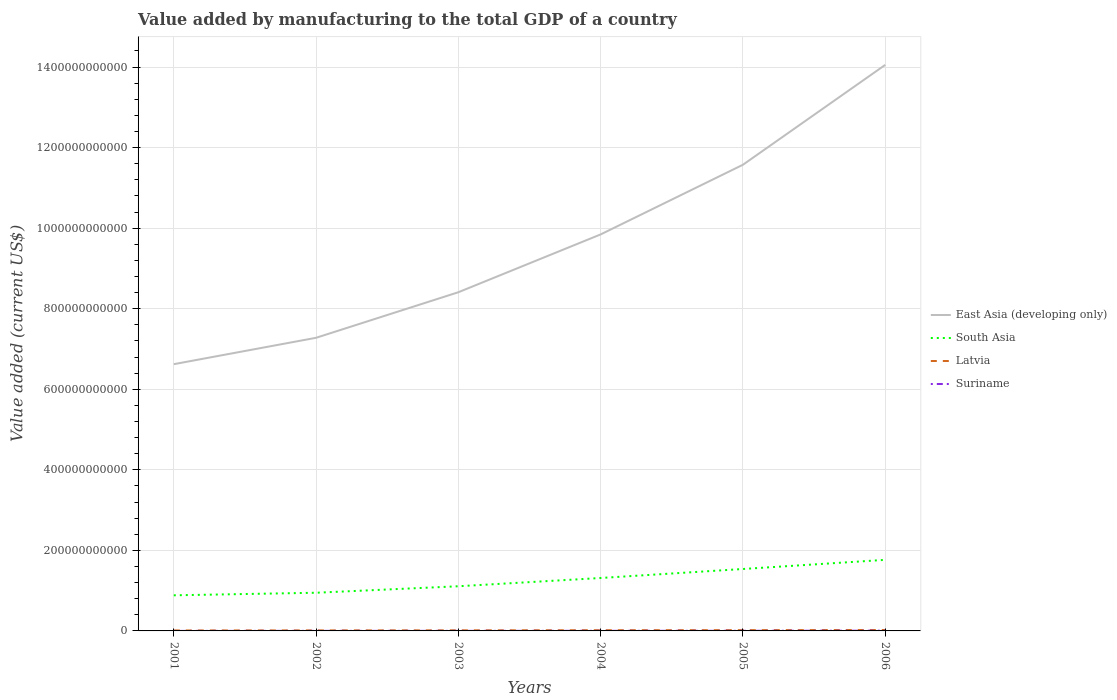How many different coloured lines are there?
Ensure brevity in your answer.  4. Does the line corresponding to Latvia intersect with the line corresponding to South Asia?
Provide a succinct answer. No. Across all years, what is the maximum value added by manufacturing to the total GDP in Suriname?
Give a very brief answer. 4.43e+07. In which year was the value added by manufacturing to the total GDP in East Asia (developing only) maximum?
Provide a succinct answer. 2001. What is the total value added by manufacturing to the total GDP in Suriname in the graph?
Ensure brevity in your answer.  -4.64e+08. What is the difference between the highest and the second highest value added by manufacturing to the total GDP in Suriname?
Your answer should be very brief. 5.65e+08. Is the value added by manufacturing to the total GDP in South Asia strictly greater than the value added by manufacturing to the total GDP in Latvia over the years?
Offer a terse response. No. How many years are there in the graph?
Provide a succinct answer. 6. What is the difference between two consecutive major ticks on the Y-axis?
Provide a short and direct response. 2.00e+11. Are the values on the major ticks of Y-axis written in scientific E-notation?
Keep it short and to the point. No. Where does the legend appear in the graph?
Make the answer very short. Center right. How are the legend labels stacked?
Provide a short and direct response. Vertical. What is the title of the graph?
Your answer should be very brief. Value added by manufacturing to the total GDP of a country. Does "Jordan" appear as one of the legend labels in the graph?
Your answer should be very brief. No. What is the label or title of the Y-axis?
Your response must be concise. Value added (current US$). What is the Value added (current US$) in East Asia (developing only) in 2001?
Your response must be concise. 6.62e+11. What is the Value added (current US$) in South Asia in 2001?
Provide a short and direct response. 8.84e+1. What is the Value added (current US$) of Latvia in 2001?
Your answer should be compact. 1.14e+09. What is the Value added (current US$) in Suriname in 2001?
Your response must be concise. 4.43e+07. What is the Value added (current US$) in East Asia (developing only) in 2002?
Keep it short and to the point. 7.28e+11. What is the Value added (current US$) in South Asia in 2002?
Give a very brief answer. 9.48e+1. What is the Value added (current US$) in Latvia in 2002?
Offer a very short reply. 1.30e+09. What is the Value added (current US$) in Suriname in 2002?
Ensure brevity in your answer.  1.45e+08. What is the Value added (current US$) of East Asia (developing only) in 2003?
Keep it short and to the point. 8.41e+11. What is the Value added (current US$) of South Asia in 2003?
Your response must be concise. 1.11e+11. What is the Value added (current US$) of Latvia in 2003?
Offer a very short reply. 1.46e+09. What is the Value added (current US$) of Suriname in 2003?
Make the answer very short. 1.62e+08. What is the Value added (current US$) in East Asia (developing only) in 2004?
Keep it short and to the point. 9.84e+11. What is the Value added (current US$) of South Asia in 2004?
Your response must be concise. 1.31e+11. What is the Value added (current US$) in Latvia in 2004?
Give a very brief answer. 1.78e+09. What is the Value added (current US$) of Suriname in 2004?
Provide a succinct answer. 2.27e+08. What is the Value added (current US$) of East Asia (developing only) in 2005?
Provide a succinct answer. 1.16e+12. What is the Value added (current US$) in South Asia in 2005?
Provide a succinct answer. 1.54e+11. What is the Value added (current US$) of Latvia in 2005?
Keep it short and to the point. 1.95e+09. What is the Value added (current US$) of Suriname in 2005?
Your response must be concise. 2.99e+08. What is the Value added (current US$) in East Asia (developing only) in 2006?
Offer a terse response. 1.41e+12. What is the Value added (current US$) of South Asia in 2006?
Your answer should be compact. 1.76e+11. What is the Value added (current US$) in Latvia in 2006?
Your answer should be very brief. 2.29e+09. What is the Value added (current US$) of Suriname in 2006?
Give a very brief answer. 6.09e+08. Across all years, what is the maximum Value added (current US$) of East Asia (developing only)?
Provide a succinct answer. 1.41e+12. Across all years, what is the maximum Value added (current US$) of South Asia?
Keep it short and to the point. 1.76e+11. Across all years, what is the maximum Value added (current US$) in Latvia?
Offer a terse response. 2.29e+09. Across all years, what is the maximum Value added (current US$) of Suriname?
Ensure brevity in your answer.  6.09e+08. Across all years, what is the minimum Value added (current US$) in East Asia (developing only)?
Offer a very short reply. 6.62e+11. Across all years, what is the minimum Value added (current US$) in South Asia?
Your response must be concise. 8.84e+1. Across all years, what is the minimum Value added (current US$) of Latvia?
Make the answer very short. 1.14e+09. Across all years, what is the minimum Value added (current US$) in Suriname?
Keep it short and to the point. 4.43e+07. What is the total Value added (current US$) of East Asia (developing only) in the graph?
Your answer should be very brief. 5.78e+12. What is the total Value added (current US$) in South Asia in the graph?
Your answer should be compact. 7.56e+11. What is the total Value added (current US$) of Latvia in the graph?
Give a very brief answer. 9.93e+09. What is the total Value added (current US$) in Suriname in the graph?
Keep it short and to the point. 1.49e+09. What is the difference between the Value added (current US$) in East Asia (developing only) in 2001 and that in 2002?
Your answer should be compact. -6.55e+1. What is the difference between the Value added (current US$) in South Asia in 2001 and that in 2002?
Your answer should be compact. -6.36e+09. What is the difference between the Value added (current US$) of Latvia in 2001 and that in 2002?
Offer a terse response. -1.57e+08. What is the difference between the Value added (current US$) in Suriname in 2001 and that in 2002?
Your answer should be very brief. -1.01e+08. What is the difference between the Value added (current US$) of East Asia (developing only) in 2001 and that in 2003?
Your response must be concise. -1.79e+11. What is the difference between the Value added (current US$) in South Asia in 2001 and that in 2003?
Provide a succinct answer. -2.25e+1. What is the difference between the Value added (current US$) of Latvia in 2001 and that in 2003?
Provide a short and direct response. -3.19e+08. What is the difference between the Value added (current US$) in Suriname in 2001 and that in 2003?
Your answer should be very brief. -1.18e+08. What is the difference between the Value added (current US$) in East Asia (developing only) in 2001 and that in 2004?
Give a very brief answer. -3.22e+11. What is the difference between the Value added (current US$) in South Asia in 2001 and that in 2004?
Offer a very short reply. -4.30e+1. What is the difference between the Value added (current US$) in Latvia in 2001 and that in 2004?
Offer a very short reply. -6.35e+08. What is the difference between the Value added (current US$) in Suriname in 2001 and that in 2004?
Your answer should be compact. -1.83e+08. What is the difference between the Value added (current US$) in East Asia (developing only) in 2001 and that in 2005?
Keep it short and to the point. -4.95e+11. What is the difference between the Value added (current US$) in South Asia in 2001 and that in 2005?
Give a very brief answer. -6.53e+1. What is the difference between the Value added (current US$) in Latvia in 2001 and that in 2005?
Your answer should be compact. -8.05e+08. What is the difference between the Value added (current US$) of Suriname in 2001 and that in 2005?
Offer a very short reply. -2.55e+08. What is the difference between the Value added (current US$) in East Asia (developing only) in 2001 and that in 2006?
Your response must be concise. -7.43e+11. What is the difference between the Value added (current US$) of South Asia in 2001 and that in 2006?
Provide a short and direct response. -8.80e+1. What is the difference between the Value added (current US$) in Latvia in 2001 and that in 2006?
Give a very brief answer. -1.14e+09. What is the difference between the Value added (current US$) in Suriname in 2001 and that in 2006?
Make the answer very short. -5.65e+08. What is the difference between the Value added (current US$) in East Asia (developing only) in 2002 and that in 2003?
Provide a succinct answer. -1.13e+11. What is the difference between the Value added (current US$) in South Asia in 2002 and that in 2003?
Ensure brevity in your answer.  -1.61e+1. What is the difference between the Value added (current US$) in Latvia in 2002 and that in 2003?
Ensure brevity in your answer.  -1.62e+08. What is the difference between the Value added (current US$) of Suriname in 2002 and that in 2003?
Ensure brevity in your answer.  -1.69e+07. What is the difference between the Value added (current US$) in East Asia (developing only) in 2002 and that in 2004?
Ensure brevity in your answer.  -2.57e+11. What is the difference between the Value added (current US$) in South Asia in 2002 and that in 2004?
Offer a very short reply. -3.66e+1. What is the difference between the Value added (current US$) of Latvia in 2002 and that in 2004?
Keep it short and to the point. -4.78e+08. What is the difference between the Value added (current US$) in Suriname in 2002 and that in 2004?
Offer a very short reply. -8.15e+07. What is the difference between the Value added (current US$) in East Asia (developing only) in 2002 and that in 2005?
Make the answer very short. -4.30e+11. What is the difference between the Value added (current US$) in South Asia in 2002 and that in 2005?
Provide a succinct answer. -5.90e+1. What is the difference between the Value added (current US$) of Latvia in 2002 and that in 2005?
Provide a succinct answer. -6.48e+08. What is the difference between the Value added (current US$) in Suriname in 2002 and that in 2005?
Keep it short and to the point. -1.54e+08. What is the difference between the Value added (current US$) in East Asia (developing only) in 2002 and that in 2006?
Your answer should be compact. -6.78e+11. What is the difference between the Value added (current US$) in South Asia in 2002 and that in 2006?
Give a very brief answer. -8.17e+1. What is the difference between the Value added (current US$) in Latvia in 2002 and that in 2006?
Give a very brief answer. -9.87e+08. What is the difference between the Value added (current US$) of Suriname in 2002 and that in 2006?
Give a very brief answer. -4.64e+08. What is the difference between the Value added (current US$) in East Asia (developing only) in 2003 and that in 2004?
Give a very brief answer. -1.44e+11. What is the difference between the Value added (current US$) of South Asia in 2003 and that in 2004?
Keep it short and to the point. -2.05e+1. What is the difference between the Value added (current US$) of Latvia in 2003 and that in 2004?
Provide a short and direct response. -3.16e+08. What is the difference between the Value added (current US$) in Suriname in 2003 and that in 2004?
Give a very brief answer. -6.46e+07. What is the difference between the Value added (current US$) in East Asia (developing only) in 2003 and that in 2005?
Your response must be concise. -3.17e+11. What is the difference between the Value added (current US$) of South Asia in 2003 and that in 2005?
Offer a very short reply. -4.29e+1. What is the difference between the Value added (current US$) in Latvia in 2003 and that in 2005?
Offer a terse response. -4.86e+08. What is the difference between the Value added (current US$) in Suriname in 2003 and that in 2005?
Your answer should be very brief. -1.37e+08. What is the difference between the Value added (current US$) in East Asia (developing only) in 2003 and that in 2006?
Offer a very short reply. -5.64e+11. What is the difference between the Value added (current US$) of South Asia in 2003 and that in 2006?
Your answer should be very brief. -6.56e+1. What is the difference between the Value added (current US$) of Latvia in 2003 and that in 2006?
Your answer should be very brief. -8.25e+08. What is the difference between the Value added (current US$) of Suriname in 2003 and that in 2006?
Offer a terse response. -4.47e+08. What is the difference between the Value added (current US$) in East Asia (developing only) in 2004 and that in 2005?
Make the answer very short. -1.73e+11. What is the difference between the Value added (current US$) of South Asia in 2004 and that in 2005?
Make the answer very short. -2.23e+1. What is the difference between the Value added (current US$) of Latvia in 2004 and that in 2005?
Your answer should be very brief. -1.70e+08. What is the difference between the Value added (current US$) of Suriname in 2004 and that in 2005?
Your answer should be compact. -7.25e+07. What is the difference between the Value added (current US$) in East Asia (developing only) in 2004 and that in 2006?
Make the answer very short. -4.21e+11. What is the difference between the Value added (current US$) in South Asia in 2004 and that in 2006?
Ensure brevity in your answer.  -4.51e+1. What is the difference between the Value added (current US$) in Latvia in 2004 and that in 2006?
Offer a terse response. -5.09e+08. What is the difference between the Value added (current US$) in Suriname in 2004 and that in 2006?
Provide a short and direct response. -3.82e+08. What is the difference between the Value added (current US$) of East Asia (developing only) in 2005 and that in 2006?
Offer a terse response. -2.48e+11. What is the difference between the Value added (current US$) in South Asia in 2005 and that in 2006?
Give a very brief answer. -2.27e+1. What is the difference between the Value added (current US$) of Latvia in 2005 and that in 2006?
Your answer should be very brief. -3.40e+08. What is the difference between the Value added (current US$) of Suriname in 2005 and that in 2006?
Ensure brevity in your answer.  -3.10e+08. What is the difference between the Value added (current US$) in East Asia (developing only) in 2001 and the Value added (current US$) in South Asia in 2002?
Your response must be concise. 5.67e+11. What is the difference between the Value added (current US$) of East Asia (developing only) in 2001 and the Value added (current US$) of Latvia in 2002?
Give a very brief answer. 6.61e+11. What is the difference between the Value added (current US$) in East Asia (developing only) in 2001 and the Value added (current US$) in Suriname in 2002?
Make the answer very short. 6.62e+11. What is the difference between the Value added (current US$) in South Asia in 2001 and the Value added (current US$) in Latvia in 2002?
Your answer should be compact. 8.71e+1. What is the difference between the Value added (current US$) in South Asia in 2001 and the Value added (current US$) in Suriname in 2002?
Make the answer very short. 8.83e+1. What is the difference between the Value added (current US$) of Latvia in 2001 and the Value added (current US$) of Suriname in 2002?
Provide a succinct answer. 9.99e+08. What is the difference between the Value added (current US$) in East Asia (developing only) in 2001 and the Value added (current US$) in South Asia in 2003?
Your answer should be compact. 5.51e+11. What is the difference between the Value added (current US$) in East Asia (developing only) in 2001 and the Value added (current US$) in Latvia in 2003?
Make the answer very short. 6.61e+11. What is the difference between the Value added (current US$) of East Asia (developing only) in 2001 and the Value added (current US$) of Suriname in 2003?
Your answer should be very brief. 6.62e+11. What is the difference between the Value added (current US$) of South Asia in 2001 and the Value added (current US$) of Latvia in 2003?
Make the answer very short. 8.70e+1. What is the difference between the Value added (current US$) in South Asia in 2001 and the Value added (current US$) in Suriname in 2003?
Offer a terse response. 8.83e+1. What is the difference between the Value added (current US$) in Latvia in 2001 and the Value added (current US$) in Suriname in 2003?
Make the answer very short. 9.83e+08. What is the difference between the Value added (current US$) in East Asia (developing only) in 2001 and the Value added (current US$) in South Asia in 2004?
Offer a very short reply. 5.31e+11. What is the difference between the Value added (current US$) in East Asia (developing only) in 2001 and the Value added (current US$) in Latvia in 2004?
Your response must be concise. 6.60e+11. What is the difference between the Value added (current US$) of East Asia (developing only) in 2001 and the Value added (current US$) of Suriname in 2004?
Ensure brevity in your answer.  6.62e+11. What is the difference between the Value added (current US$) of South Asia in 2001 and the Value added (current US$) of Latvia in 2004?
Offer a terse response. 8.66e+1. What is the difference between the Value added (current US$) of South Asia in 2001 and the Value added (current US$) of Suriname in 2004?
Ensure brevity in your answer.  8.82e+1. What is the difference between the Value added (current US$) of Latvia in 2001 and the Value added (current US$) of Suriname in 2004?
Provide a succinct answer. 9.18e+08. What is the difference between the Value added (current US$) in East Asia (developing only) in 2001 and the Value added (current US$) in South Asia in 2005?
Keep it short and to the point. 5.09e+11. What is the difference between the Value added (current US$) of East Asia (developing only) in 2001 and the Value added (current US$) of Latvia in 2005?
Your response must be concise. 6.60e+11. What is the difference between the Value added (current US$) of East Asia (developing only) in 2001 and the Value added (current US$) of Suriname in 2005?
Offer a very short reply. 6.62e+11. What is the difference between the Value added (current US$) in South Asia in 2001 and the Value added (current US$) in Latvia in 2005?
Ensure brevity in your answer.  8.65e+1. What is the difference between the Value added (current US$) in South Asia in 2001 and the Value added (current US$) in Suriname in 2005?
Ensure brevity in your answer.  8.81e+1. What is the difference between the Value added (current US$) of Latvia in 2001 and the Value added (current US$) of Suriname in 2005?
Give a very brief answer. 8.45e+08. What is the difference between the Value added (current US$) of East Asia (developing only) in 2001 and the Value added (current US$) of South Asia in 2006?
Ensure brevity in your answer.  4.86e+11. What is the difference between the Value added (current US$) in East Asia (developing only) in 2001 and the Value added (current US$) in Latvia in 2006?
Ensure brevity in your answer.  6.60e+11. What is the difference between the Value added (current US$) of East Asia (developing only) in 2001 and the Value added (current US$) of Suriname in 2006?
Your answer should be very brief. 6.62e+11. What is the difference between the Value added (current US$) of South Asia in 2001 and the Value added (current US$) of Latvia in 2006?
Offer a very short reply. 8.61e+1. What is the difference between the Value added (current US$) of South Asia in 2001 and the Value added (current US$) of Suriname in 2006?
Give a very brief answer. 8.78e+1. What is the difference between the Value added (current US$) in Latvia in 2001 and the Value added (current US$) in Suriname in 2006?
Provide a short and direct response. 5.36e+08. What is the difference between the Value added (current US$) of East Asia (developing only) in 2002 and the Value added (current US$) of South Asia in 2003?
Give a very brief answer. 6.17e+11. What is the difference between the Value added (current US$) in East Asia (developing only) in 2002 and the Value added (current US$) in Latvia in 2003?
Offer a terse response. 7.26e+11. What is the difference between the Value added (current US$) of East Asia (developing only) in 2002 and the Value added (current US$) of Suriname in 2003?
Provide a short and direct response. 7.28e+11. What is the difference between the Value added (current US$) of South Asia in 2002 and the Value added (current US$) of Latvia in 2003?
Provide a succinct answer. 9.33e+1. What is the difference between the Value added (current US$) of South Asia in 2002 and the Value added (current US$) of Suriname in 2003?
Your response must be concise. 9.46e+1. What is the difference between the Value added (current US$) of Latvia in 2002 and the Value added (current US$) of Suriname in 2003?
Ensure brevity in your answer.  1.14e+09. What is the difference between the Value added (current US$) of East Asia (developing only) in 2002 and the Value added (current US$) of South Asia in 2004?
Give a very brief answer. 5.96e+11. What is the difference between the Value added (current US$) of East Asia (developing only) in 2002 and the Value added (current US$) of Latvia in 2004?
Offer a very short reply. 7.26e+11. What is the difference between the Value added (current US$) in East Asia (developing only) in 2002 and the Value added (current US$) in Suriname in 2004?
Provide a short and direct response. 7.28e+11. What is the difference between the Value added (current US$) in South Asia in 2002 and the Value added (current US$) in Latvia in 2004?
Make the answer very short. 9.30e+1. What is the difference between the Value added (current US$) in South Asia in 2002 and the Value added (current US$) in Suriname in 2004?
Make the answer very short. 9.46e+1. What is the difference between the Value added (current US$) of Latvia in 2002 and the Value added (current US$) of Suriname in 2004?
Offer a very short reply. 1.08e+09. What is the difference between the Value added (current US$) of East Asia (developing only) in 2002 and the Value added (current US$) of South Asia in 2005?
Offer a very short reply. 5.74e+11. What is the difference between the Value added (current US$) of East Asia (developing only) in 2002 and the Value added (current US$) of Latvia in 2005?
Give a very brief answer. 7.26e+11. What is the difference between the Value added (current US$) in East Asia (developing only) in 2002 and the Value added (current US$) in Suriname in 2005?
Keep it short and to the point. 7.27e+11. What is the difference between the Value added (current US$) of South Asia in 2002 and the Value added (current US$) of Latvia in 2005?
Ensure brevity in your answer.  9.28e+1. What is the difference between the Value added (current US$) in South Asia in 2002 and the Value added (current US$) in Suriname in 2005?
Your answer should be very brief. 9.45e+1. What is the difference between the Value added (current US$) in Latvia in 2002 and the Value added (current US$) in Suriname in 2005?
Offer a very short reply. 1.00e+09. What is the difference between the Value added (current US$) of East Asia (developing only) in 2002 and the Value added (current US$) of South Asia in 2006?
Ensure brevity in your answer.  5.51e+11. What is the difference between the Value added (current US$) of East Asia (developing only) in 2002 and the Value added (current US$) of Latvia in 2006?
Keep it short and to the point. 7.25e+11. What is the difference between the Value added (current US$) in East Asia (developing only) in 2002 and the Value added (current US$) in Suriname in 2006?
Your answer should be very brief. 7.27e+11. What is the difference between the Value added (current US$) in South Asia in 2002 and the Value added (current US$) in Latvia in 2006?
Offer a very short reply. 9.25e+1. What is the difference between the Value added (current US$) of South Asia in 2002 and the Value added (current US$) of Suriname in 2006?
Your response must be concise. 9.42e+1. What is the difference between the Value added (current US$) of Latvia in 2002 and the Value added (current US$) of Suriname in 2006?
Keep it short and to the point. 6.93e+08. What is the difference between the Value added (current US$) of East Asia (developing only) in 2003 and the Value added (current US$) of South Asia in 2004?
Your response must be concise. 7.09e+11. What is the difference between the Value added (current US$) in East Asia (developing only) in 2003 and the Value added (current US$) in Latvia in 2004?
Offer a very short reply. 8.39e+11. What is the difference between the Value added (current US$) of East Asia (developing only) in 2003 and the Value added (current US$) of Suriname in 2004?
Your answer should be compact. 8.41e+11. What is the difference between the Value added (current US$) of South Asia in 2003 and the Value added (current US$) of Latvia in 2004?
Ensure brevity in your answer.  1.09e+11. What is the difference between the Value added (current US$) of South Asia in 2003 and the Value added (current US$) of Suriname in 2004?
Make the answer very short. 1.11e+11. What is the difference between the Value added (current US$) in Latvia in 2003 and the Value added (current US$) in Suriname in 2004?
Ensure brevity in your answer.  1.24e+09. What is the difference between the Value added (current US$) of East Asia (developing only) in 2003 and the Value added (current US$) of South Asia in 2005?
Provide a succinct answer. 6.87e+11. What is the difference between the Value added (current US$) of East Asia (developing only) in 2003 and the Value added (current US$) of Latvia in 2005?
Offer a very short reply. 8.39e+11. What is the difference between the Value added (current US$) of East Asia (developing only) in 2003 and the Value added (current US$) of Suriname in 2005?
Your answer should be compact. 8.41e+11. What is the difference between the Value added (current US$) of South Asia in 2003 and the Value added (current US$) of Latvia in 2005?
Your answer should be very brief. 1.09e+11. What is the difference between the Value added (current US$) in South Asia in 2003 and the Value added (current US$) in Suriname in 2005?
Give a very brief answer. 1.11e+11. What is the difference between the Value added (current US$) in Latvia in 2003 and the Value added (current US$) in Suriname in 2005?
Offer a terse response. 1.16e+09. What is the difference between the Value added (current US$) of East Asia (developing only) in 2003 and the Value added (current US$) of South Asia in 2006?
Offer a very short reply. 6.64e+11. What is the difference between the Value added (current US$) in East Asia (developing only) in 2003 and the Value added (current US$) in Latvia in 2006?
Ensure brevity in your answer.  8.39e+11. What is the difference between the Value added (current US$) in East Asia (developing only) in 2003 and the Value added (current US$) in Suriname in 2006?
Keep it short and to the point. 8.40e+11. What is the difference between the Value added (current US$) of South Asia in 2003 and the Value added (current US$) of Latvia in 2006?
Ensure brevity in your answer.  1.09e+11. What is the difference between the Value added (current US$) in South Asia in 2003 and the Value added (current US$) in Suriname in 2006?
Give a very brief answer. 1.10e+11. What is the difference between the Value added (current US$) in Latvia in 2003 and the Value added (current US$) in Suriname in 2006?
Offer a very short reply. 8.55e+08. What is the difference between the Value added (current US$) of East Asia (developing only) in 2004 and the Value added (current US$) of South Asia in 2005?
Provide a succinct answer. 8.31e+11. What is the difference between the Value added (current US$) in East Asia (developing only) in 2004 and the Value added (current US$) in Latvia in 2005?
Offer a very short reply. 9.82e+11. What is the difference between the Value added (current US$) of East Asia (developing only) in 2004 and the Value added (current US$) of Suriname in 2005?
Provide a succinct answer. 9.84e+11. What is the difference between the Value added (current US$) of South Asia in 2004 and the Value added (current US$) of Latvia in 2005?
Keep it short and to the point. 1.29e+11. What is the difference between the Value added (current US$) of South Asia in 2004 and the Value added (current US$) of Suriname in 2005?
Give a very brief answer. 1.31e+11. What is the difference between the Value added (current US$) of Latvia in 2004 and the Value added (current US$) of Suriname in 2005?
Offer a very short reply. 1.48e+09. What is the difference between the Value added (current US$) in East Asia (developing only) in 2004 and the Value added (current US$) in South Asia in 2006?
Your response must be concise. 8.08e+11. What is the difference between the Value added (current US$) in East Asia (developing only) in 2004 and the Value added (current US$) in Latvia in 2006?
Keep it short and to the point. 9.82e+11. What is the difference between the Value added (current US$) of East Asia (developing only) in 2004 and the Value added (current US$) of Suriname in 2006?
Make the answer very short. 9.84e+11. What is the difference between the Value added (current US$) of South Asia in 2004 and the Value added (current US$) of Latvia in 2006?
Provide a short and direct response. 1.29e+11. What is the difference between the Value added (current US$) of South Asia in 2004 and the Value added (current US$) of Suriname in 2006?
Make the answer very short. 1.31e+11. What is the difference between the Value added (current US$) in Latvia in 2004 and the Value added (current US$) in Suriname in 2006?
Your response must be concise. 1.17e+09. What is the difference between the Value added (current US$) in East Asia (developing only) in 2005 and the Value added (current US$) in South Asia in 2006?
Keep it short and to the point. 9.81e+11. What is the difference between the Value added (current US$) in East Asia (developing only) in 2005 and the Value added (current US$) in Latvia in 2006?
Give a very brief answer. 1.16e+12. What is the difference between the Value added (current US$) in East Asia (developing only) in 2005 and the Value added (current US$) in Suriname in 2006?
Offer a very short reply. 1.16e+12. What is the difference between the Value added (current US$) in South Asia in 2005 and the Value added (current US$) in Latvia in 2006?
Your answer should be very brief. 1.51e+11. What is the difference between the Value added (current US$) in South Asia in 2005 and the Value added (current US$) in Suriname in 2006?
Offer a very short reply. 1.53e+11. What is the difference between the Value added (current US$) in Latvia in 2005 and the Value added (current US$) in Suriname in 2006?
Your answer should be very brief. 1.34e+09. What is the average Value added (current US$) in East Asia (developing only) per year?
Your answer should be compact. 9.63e+11. What is the average Value added (current US$) of South Asia per year?
Provide a short and direct response. 1.26e+11. What is the average Value added (current US$) in Latvia per year?
Make the answer very short. 1.66e+09. What is the average Value added (current US$) of Suriname per year?
Offer a terse response. 2.48e+08. In the year 2001, what is the difference between the Value added (current US$) of East Asia (developing only) and Value added (current US$) of South Asia?
Your response must be concise. 5.74e+11. In the year 2001, what is the difference between the Value added (current US$) of East Asia (developing only) and Value added (current US$) of Latvia?
Your response must be concise. 6.61e+11. In the year 2001, what is the difference between the Value added (current US$) in East Asia (developing only) and Value added (current US$) in Suriname?
Offer a terse response. 6.62e+11. In the year 2001, what is the difference between the Value added (current US$) of South Asia and Value added (current US$) of Latvia?
Ensure brevity in your answer.  8.73e+1. In the year 2001, what is the difference between the Value added (current US$) of South Asia and Value added (current US$) of Suriname?
Offer a very short reply. 8.84e+1. In the year 2001, what is the difference between the Value added (current US$) of Latvia and Value added (current US$) of Suriname?
Ensure brevity in your answer.  1.10e+09. In the year 2002, what is the difference between the Value added (current US$) in East Asia (developing only) and Value added (current US$) in South Asia?
Provide a succinct answer. 6.33e+11. In the year 2002, what is the difference between the Value added (current US$) in East Asia (developing only) and Value added (current US$) in Latvia?
Provide a short and direct response. 7.26e+11. In the year 2002, what is the difference between the Value added (current US$) of East Asia (developing only) and Value added (current US$) of Suriname?
Your answer should be compact. 7.28e+11. In the year 2002, what is the difference between the Value added (current US$) in South Asia and Value added (current US$) in Latvia?
Your response must be concise. 9.35e+1. In the year 2002, what is the difference between the Value added (current US$) in South Asia and Value added (current US$) in Suriname?
Your answer should be very brief. 9.46e+1. In the year 2002, what is the difference between the Value added (current US$) in Latvia and Value added (current US$) in Suriname?
Keep it short and to the point. 1.16e+09. In the year 2003, what is the difference between the Value added (current US$) in East Asia (developing only) and Value added (current US$) in South Asia?
Keep it short and to the point. 7.30e+11. In the year 2003, what is the difference between the Value added (current US$) of East Asia (developing only) and Value added (current US$) of Latvia?
Provide a succinct answer. 8.39e+11. In the year 2003, what is the difference between the Value added (current US$) of East Asia (developing only) and Value added (current US$) of Suriname?
Your answer should be compact. 8.41e+11. In the year 2003, what is the difference between the Value added (current US$) in South Asia and Value added (current US$) in Latvia?
Offer a very short reply. 1.09e+11. In the year 2003, what is the difference between the Value added (current US$) of South Asia and Value added (current US$) of Suriname?
Your response must be concise. 1.11e+11. In the year 2003, what is the difference between the Value added (current US$) of Latvia and Value added (current US$) of Suriname?
Your answer should be compact. 1.30e+09. In the year 2004, what is the difference between the Value added (current US$) of East Asia (developing only) and Value added (current US$) of South Asia?
Ensure brevity in your answer.  8.53e+11. In the year 2004, what is the difference between the Value added (current US$) of East Asia (developing only) and Value added (current US$) of Latvia?
Offer a very short reply. 9.83e+11. In the year 2004, what is the difference between the Value added (current US$) in East Asia (developing only) and Value added (current US$) in Suriname?
Offer a very short reply. 9.84e+11. In the year 2004, what is the difference between the Value added (current US$) in South Asia and Value added (current US$) in Latvia?
Keep it short and to the point. 1.30e+11. In the year 2004, what is the difference between the Value added (current US$) of South Asia and Value added (current US$) of Suriname?
Ensure brevity in your answer.  1.31e+11. In the year 2004, what is the difference between the Value added (current US$) in Latvia and Value added (current US$) in Suriname?
Your answer should be very brief. 1.55e+09. In the year 2005, what is the difference between the Value added (current US$) in East Asia (developing only) and Value added (current US$) in South Asia?
Your response must be concise. 1.00e+12. In the year 2005, what is the difference between the Value added (current US$) in East Asia (developing only) and Value added (current US$) in Latvia?
Ensure brevity in your answer.  1.16e+12. In the year 2005, what is the difference between the Value added (current US$) in East Asia (developing only) and Value added (current US$) in Suriname?
Provide a succinct answer. 1.16e+12. In the year 2005, what is the difference between the Value added (current US$) of South Asia and Value added (current US$) of Latvia?
Give a very brief answer. 1.52e+11. In the year 2005, what is the difference between the Value added (current US$) in South Asia and Value added (current US$) in Suriname?
Give a very brief answer. 1.53e+11. In the year 2005, what is the difference between the Value added (current US$) of Latvia and Value added (current US$) of Suriname?
Your answer should be very brief. 1.65e+09. In the year 2006, what is the difference between the Value added (current US$) in East Asia (developing only) and Value added (current US$) in South Asia?
Provide a short and direct response. 1.23e+12. In the year 2006, what is the difference between the Value added (current US$) of East Asia (developing only) and Value added (current US$) of Latvia?
Your answer should be compact. 1.40e+12. In the year 2006, what is the difference between the Value added (current US$) of East Asia (developing only) and Value added (current US$) of Suriname?
Your answer should be very brief. 1.40e+12. In the year 2006, what is the difference between the Value added (current US$) in South Asia and Value added (current US$) in Latvia?
Ensure brevity in your answer.  1.74e+11. In the year 2006, what is the difference between the Value added (current US$) of South Asia and Value added (current US$) of Suriname?
Offer a terse response. 1.76e+11. In the year 2006, what is the difference between the Value added (current US$) of Latvia and Value added (current US$) of Suriname?
Give a very brief answer. 1.68e+09. What is the ratio of the Value added (current US$) in East Asia (developing only) in 2001 to that in 2002?
Your answer should be compact. 0.91. What is the ratio of the Value added (current US$) in South Asia in 2001 to that in 2002?
Your response must be concise. 0.93. What is the ratio of the Value added (current US$) in Latvia in 2001 to that in 2002?
Your response must be concise. 0.88. What is the ratio of the Value added (current US$) of Suriname in 2001 to that in 2002?
Offer a very short reply. 0.3. What is the ratio of the Value added (current US$) in East Asia (developing only) in 2001 to that in 2003?
Give a very brief answer. 0.79. What is the ratio of the Value added (current US$) of South Asia in 2001 to that in 2003?
Make the answer very short. 0.8. What is the ratio of the Value added (current US$) of Latvia in 2001 to that in 2003?
Make the answer very short. 0.78. What is the ratio of the Value added (current US$) in Suriname in 2001 to that in 2003?
Provide a short and direct response. 0.27. What is the ratio of the Value added (current US$) of East Asia (developing only) in 2001 to that in 2004?
Provide a short and direct response. 0.67. What is the ratio of the Value added (current US$) in South Asia in 2001 to that in 2004?
Make the answer very short. 0.67. What is the ratio of the Value added (current US$) in Latvia in 2001 to that in 2004?
Your answer should be very brief. 0.64. What is the ratio of the Value added (current US$) in Suriname in 2001 to that in 2004?
Your answer should be compact. 0.2. What is the ratio of the Value added (current US$) in East Asia (developing only) in 2001 to that in 2005?
Offer a terse response. 0.57. What is the ratio of the Value added (current US$) of South Asia in 2001 to that in 2005?
Your answer should be compact. 0.58. What is the ratio of the Value added (current US$) of Latvia in 2001 to that in 2005?
Make the answer very short. 0.59. What is the ratio of the Value added (current US$) of Suriname in 2001 to that in 2005?
Ensure brevity in your answer.  0.15. What is the ratio of the Value added (current US$) in East Asia (developing only) in 2001 to that in 2006?
Make the answer very short. 0.47. What is the ratio of the Value added (current US$) in South Asia in 2001 to that in 2006?
Make the answer very short. 0.5. What is the ratio of the Value added (current US$) in Latvia in 2001 to that in 2006?
Keep it short and to the point. 0.5. What is the ratio of the Value added (current US$) of Suriname in 2001 to that in 2006?
Provide a succinct answer. 0.07. What is the ratio of the Value added (current US$) in East Asia (developing only) in 2002 to that in 2003?
Your answer should be compact. 0.87. What is the ratio of the Value added (current US$) of South Asia in 2002 to that in 2003?
Keep it short and to the point. 0.85. What is the ratio of the Value added (current US$) of Latvia in 2002 to that in 2003?
Your answer should be compact. 0.89. What is the ratio of the Value added (current US$) of Suriname in 2002 to that in 2003?
Your answer should be compact. 0.9. What is the ratio of the Value added (current US$) in East Asia (developing only) in 2002 to that in 2004?
Your answer should be compact. 0.74. What is the ratio of the Value added (current US$) in South Asia in 2002 to that in 2004?
Offer a terse response. 0.72. What is the ratio of the Value added (current US$) in Latvia in 2002 to that in 2004?
Keep it short and to the point. 0.73. What is the ratio of the Value added (current US$) in Suriname in 2002 to that in 2004?
Provide a succinct answer. 0.64. What is the ratio of the Value added (current US$) in East Asia (developing only) in 2002 to that in 2005?
Provide a succinct answer. 0.63. What is the ratio of the Value added (current US$) of South Asia in 2002 to that in 2005?
Ensure brevity in your answer.  0.62. What is the ratio of the Value added (current US$) in Latvia in 2002 to that in 2005?
Offer a terse response. 0.67. What is the ratio of the Value added (current US$) in Suriname in 2002 to that in 2005?
Offer a terse response. 0.49. What is the ratio of the Value added (current US$) in East Asia (developing only) in 2002 to that in 2006?
Your answer should be compact. 0.52. What is the ratio of the Value added (current US$) in South Asia in 2002 to that in 2006?
Offer a very short reply. 0.54. What is the ratio of the Value added (current US$) in Latvia in 2002 to that in 2006?
Keep it short and to the point. 0.57. What is the ratio of the Value added (current US$) in Suriname in 2002 to that in 2006?
Your answer should be very brief. 0.24. What is the ratio of the Value added (current US$) of East Asia (developing only) in 2003 to that in 2004?
Give a very brief answer. 0.85. What is the ratio of the Value added (current US$) in South Asia in 2003 to that in 2004?
Make the answer very short. 0.84. What is the ratio of the Value added (current US$) in Latvia in 2003 to that in 2004?
Offer a terse response. 0.82. What is the ratio of the Value added (current US$) of Suriname in 2003 to that in 2004?
Your answer should be very brief. 0.72. What is the ratio of the Value added (current US$) in East Asia (developing only) in 2003 to that in 2005?
Keep it short and to the point. 0.73. What is the ratio of the Value added (current US$) of South Asia in 2003 to that in 2005?
Offer a terse response. 0.72. What is the ratio of the Value added (current US$) of Latvia in 2003 to that in 2005?
Offer a terse response. 0.75. What is the ratio of the Value added (current US$) in Suriname in 2003 to that in 2005?
Provide a short and direct response. 0.54. What is the ratio of the Value added (current US$) of East Asia (developing only) in 2003 to that in 2006?
Offer a very short reply. 0.6. What is the ratio of the Value added (current US$) in South Asia in 2003 to that in 2006?
Your response must be concise. 0.63. What is the ratio of the Value added (current US$) of Latvia in 2003 to that in 2006?
Ensure brevity in your answer.  0.64. What is the ratio of the Value added (current US$) in Suriname in 2003 to that in 2006?
Offer a very short reply. 0.27. What is the ratio of the Value added (current US$) of East Asia (developing only) in 2004 to that in 2005?
Offer a terse response. 0.85. What is the ratio of the Value added (current US$) of South Asia in 2004 to that in 2005?
Ensure brevity in your answer.  0.85. What is the ratio of the Value added (current US$) in Latvia in 2004 to that in 2005?
Ensure brevity in your answer.  0.91. What is the ratio of the Value added (current US$) of Suriname in 2004 to that in 2005?
Provide a succinct answer. 0.76. What is the ratio of the Value added (current US$) in East Asia (developing only) in 2004 to that in 2006?
Provide a short and direct response. 0.7. What is the ratio of the Value added (current US$) of South Asia in 2004 to that in 2006?
Your response must be concise. 0.74. What is the ratio of the Value added (current US$) of Latvia in 2004 to that in 2006?
Your answer should be compact. 0.78. What is the ratio of the Value added (current US$) of Suriname in 2004 to that in 2006?
Ensure brevity in your answer.  0.37. What is the ratio of the Value added (current US$) in East Asia (developing only) in 2005 to that in 2006?
Offer a very short reply. 0.82. What is the ratio of the Value added (current US$) of South Asia in 2005 to that in 2006?
Make the answer very short. 0.87. What is the ratio of the Value added (current US$) of Latvia in 2005 to that in 2006?
Your response must be concise. 0.85. What is the ratio of the Value added (current US$) of Suriname in 2005 to that in 2006?
Provide a succinct answer. 0.49. What is the difference between the highest and the second highest Value added (current US$) of East Asia (developing only)?
Offer a terse response. 2.48e+11. What is the difference between the highest and the second highest Value added (current US$) of South Asia?
Your answer should be compact. 2.27e+1. What is the difference between the highest and the second highest Value added (current US$) of Latvia?
Give a very brief answer. 3.40e+08. What is the difference between the highest and the second highest Value added (current US$) of Suriname?
Keep it short and to the point. 3.10e+08. What is the difference between the highest and the lowest Value added (current US$) in East Asia (developing only)?
Offer a very short reply. 7.43e+11. What is the difference between the highest and the lowest Value added (current US$) of South Asia?
Your response must be concise. 8.80e+1. What is the difference between the highest and the lowest Value added (current US$) of Latvia?
Your answer should be compact. 1.14e+09. What is the difference between the highest and the lowest Value added (current US$) in Suriname?
Ensure brevity in your answer.  5.65e+08. 